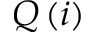<formula> <loc_0><loc_0><loc_500><loc_500>Q \, ( i )</formula> 